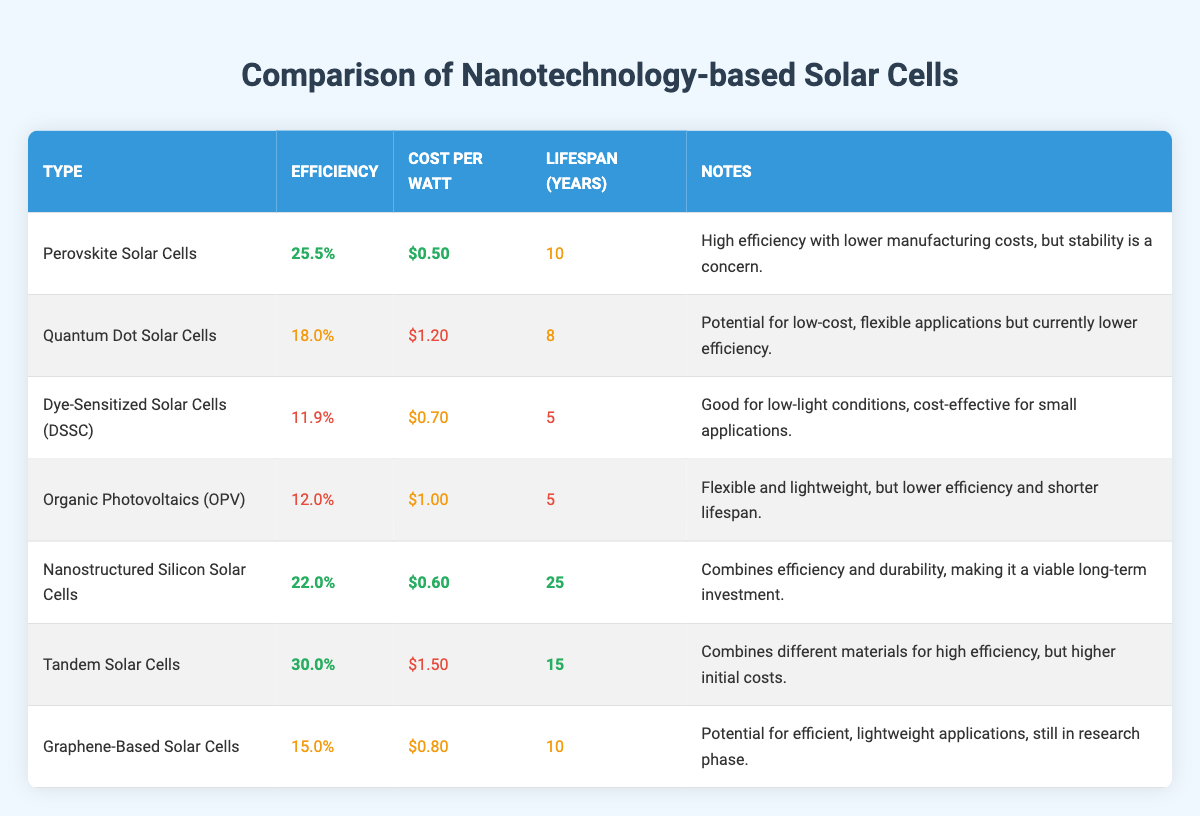What is the efficiency of Tandem Solar Cells? The table lists the efficiency of Tandem Solar Cells as 30.0%.
Answer: 30.0% Which type of solar cell has the highest lifespan? By comparing the values in the Lifespan column, Nanostructured Silicon Solar Cells have the highest lifespan at 25 years.
Answer: Nanostructured Silicon Solar Cells What is the cost per watt of Quantum Dot Solar Cells? The table shows that the cost per watt for Quantum Dot Solar Cells is $1.20.
Answer: $1.20 Which solar cell type has the lowest efficiency? Looking at the Efficiency column, Dye-Sensitized Solar Cells (DSSC) have the lowest efficiency at 11.9%.
Answer: Dye-Sensitized Solar Cells (DSSC) What is the average efficiency of the solar cells listed in the table? To find the average, sum the efficiencies: 25.5% + 18.0% + 11.9% + 12.0% + 22.0% + 30.0% + 15.0% = 134.4%. There are 7 entries, so the average efficiency is 134.4% / 7 = 19.2%.
Answer: 19.2% Is the cost per watt of Nanostructured Silicon Solar Cells lower than $0.70? The cost per watt of Nanostructured Silicon Solar Cells is $0.60, which is lower than $0.70.
Answer: Yes How many solar cells have a lifespan of 10 years or more? By counting the Lifespan column, Perovskite Solar Cells, Nanostructured Silicon Solar Cells, Tandem Solar Cells, and Graphene-Based Solar Cells have a lifespan of 10 years or more, totaling 4 types.
Answer: 4 Which solar cell type is both efficient and cost-effective? By reviewing the Efficiency and Cost per Watt columns, Perovskite Solar Cells have a good efficiency of 25.5% and a low cost of $0.50 per watt, indicating they are efficient and cost-effective.
Answer: Perovskite Solar Cells What is the efficiency difference between Tandem Solar Cells and Dye-Sensitized Solar Cells (DSSC)? Tandem Solar Cells have an efficiency of 30.0%, while DSSC has an efficiency of 11.9%. The difference is 30.0% - 11.9% = 18.1%.
Answer: 18.1% Do Graphene-Based Solar Cells have a higher efficiency than Organic Photovoltaics (OPV)? Graphene-Based Solar Cells have an efficiency of 15.0%, and OPV has an efficiency of 12.0%. Since 15.0% is greater than 12.0%, the statement is true.
Answer: Yes 